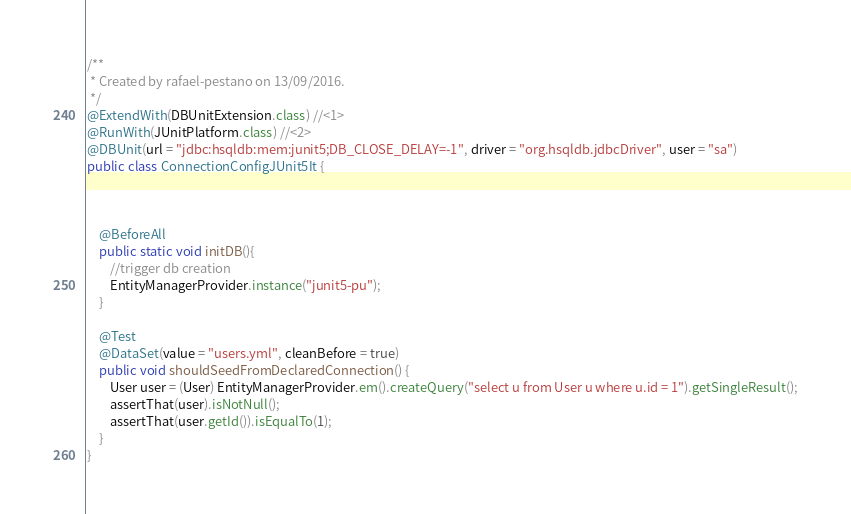Convert code to text. <code><loc_0><loc_0><loc_500><loc_500><_Java_>/**
 * Created by rafael-pestano on 13/09/2016.
 */
@ExtendWith(DBUnitExtension.class) //<1>
@RunWith(JUnitPlatform.class) //<2>
@DBUnit(url = "jdbc:hsqldb:mem:junit5;DB_CLOSE_DELAY=-1", driver = "org.hsqldb.jdbcDriver", user = "sa")
public class ConnectionConfigJUnit5It {



    @BeforeAll
    public static void initDB(){
        //trigger db creation
        EntityManagerProvider.instance("junit5-pu");
    }

    @Test
    @DataSet(value = "users.yml", cleanBefore = true)
    public void shouldSeedFromDeclaredConnection() {
        User user = (User) EntityManagerProvider.em().createQuery("select u from User u where u.id = 1").getSingleResult();
        assertThat(user).isNotNull();
        assertThat(user.getId()).isEqualTo(1);
    }
}
</code> 